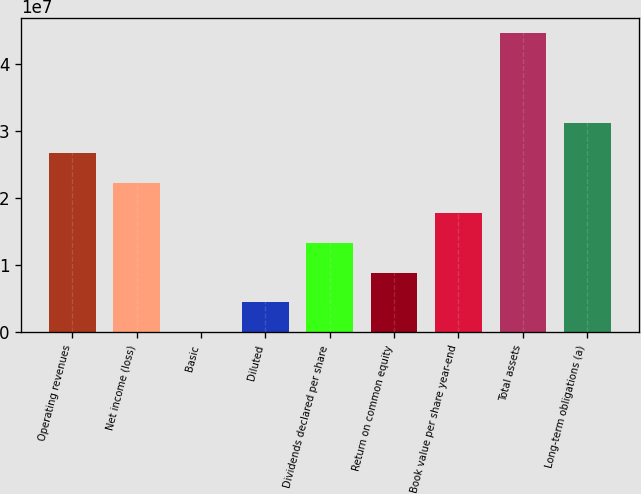Convert chart. <chart><loc_0><loc_0><loc_500><loc_500><bar_chart><fcel>Operating revenues<fcel>Net income (loss)<fcel>Basic<fcel>Diluted<fcel>Dividends declared per share<fcel>Return on common equity<fcel>Book value per share year-end<fcel>Total assets<fcel>Long-term obligations (a)<nl><fcel>2.67886e+07<fcel>2.23238e+07<fcel>0.99<fcel>4.46477e+06<fcel>1.33943e+07<fcel>8.92954e+06<fcel>1.78591e+07<fcel>4.46477e+07<fcel>3.12534e+07<nl></chart> 